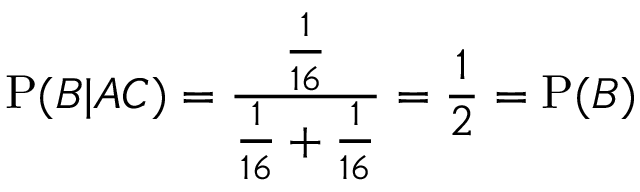Convert formula to latex. <formula><loc_0><loc_0><loc_500><loc_500>P ( B | A C ) = { \frac { \frac { 1 } { 1 6 } } { { \frac { 1 } { 1 6 } } + { \frac { 1 } { 1 6 } } } } = { \frac { 1 } { 2 } } = P ( B )</formula> 